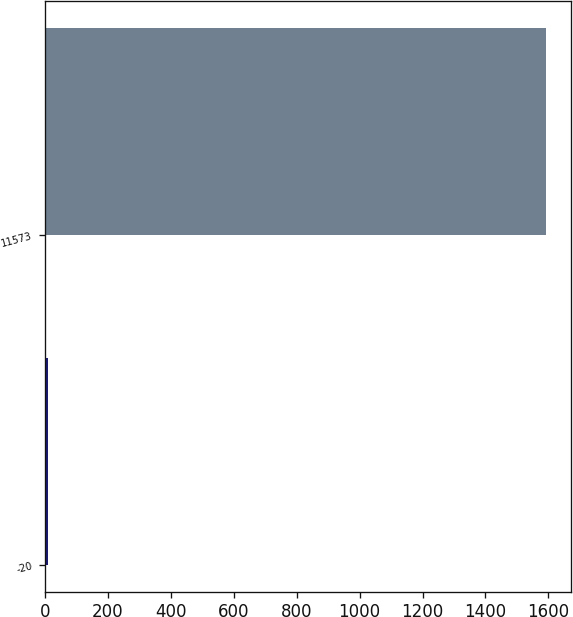<chart> <loc_0><loc_0><loc_500><loc_500><bar_chart><fcel>-20<fcel>11573<nl><fcel>10<fcel>1591.3<nl></chart> 